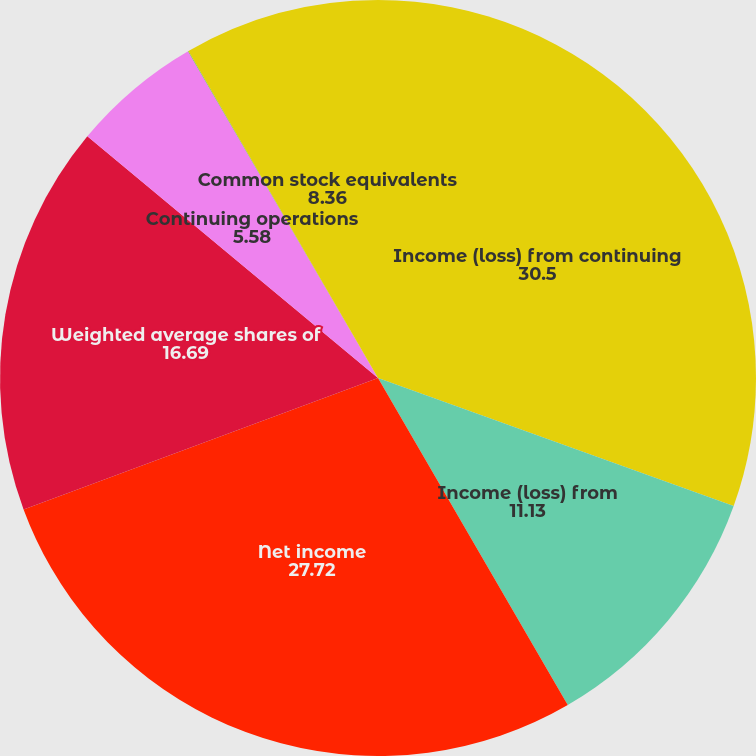<chart> <loc_0><loc_0><loc_500><loc_500><pie_chart><fcel>Income (loss) from continuing<fcel>Income (loss) from<fcel>Net income<fcel>Weighted average shares of<fcel>Continuing operations<fcel>Net income (loss) per share -<fcel>Common stock equivalents<nl><fcel>30.5%<fcel>11.13%<fcel>27.72%<fcel>16.69%<fcel>5.58%<fcel>0.02%<fcel>8.36%<nl></chart> 